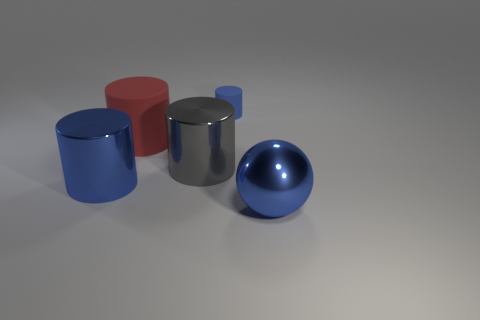Can you tell me what colors appear on the objects in this image? Certainly! There are objects in shades of blue, red, and grey in the image. Specifically, there's a blue cylinder, a red cylinder, a grey metallic cylinder, and a blue metallic ball. 